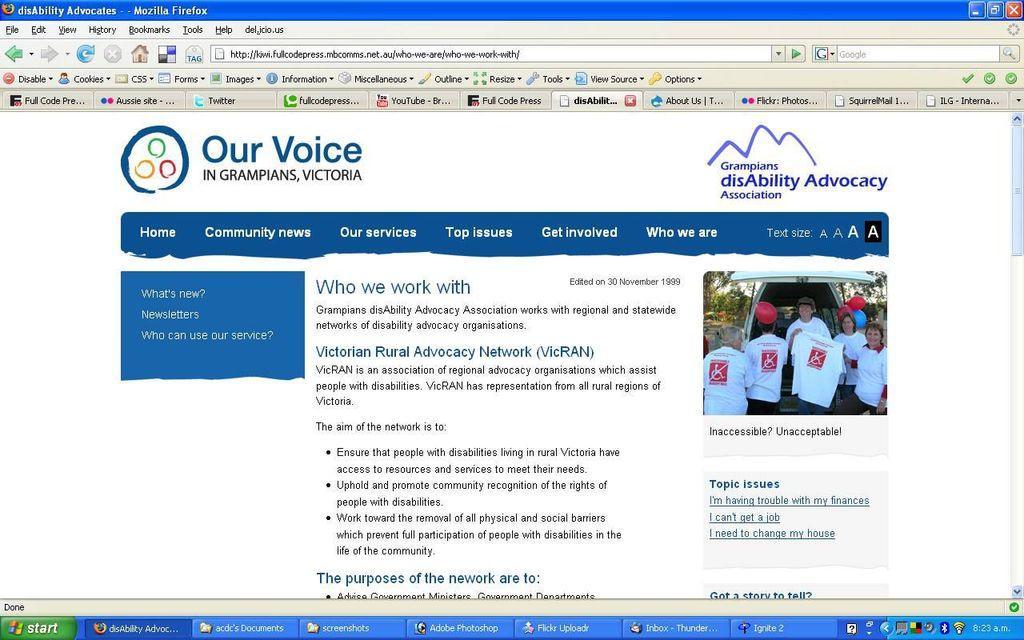Could you give a brief overview of what you see in this image? In this image, we can see a webpage contains a picture and some text. There is a search bar at the top of the image. 